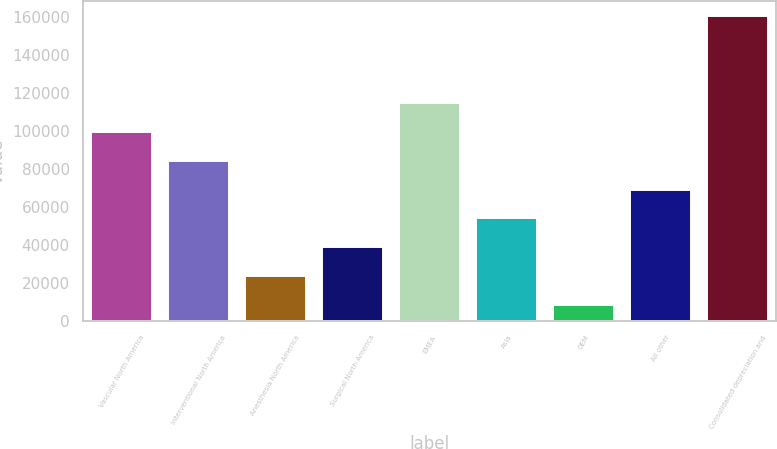<chart> <loc_0><loc_0><loc_500><loc_500><bar_chart><fcel>Vascular North America<fcel>Interventional North America<fcel>Anesthesia North America<fcel>Surgical North America<fcel>EMEA<fcel>Asia<fcel>OEM<fcel>All other<fcel>Consolidated depreciation and<nl><fcel>99537.6<fcel>84337.5<fcel>23537.1<fcel>38737.2<fcel>114738<fcel>53937.3<fcel>8337<fcel>69137.4<fcel>160338<nl></chart> 